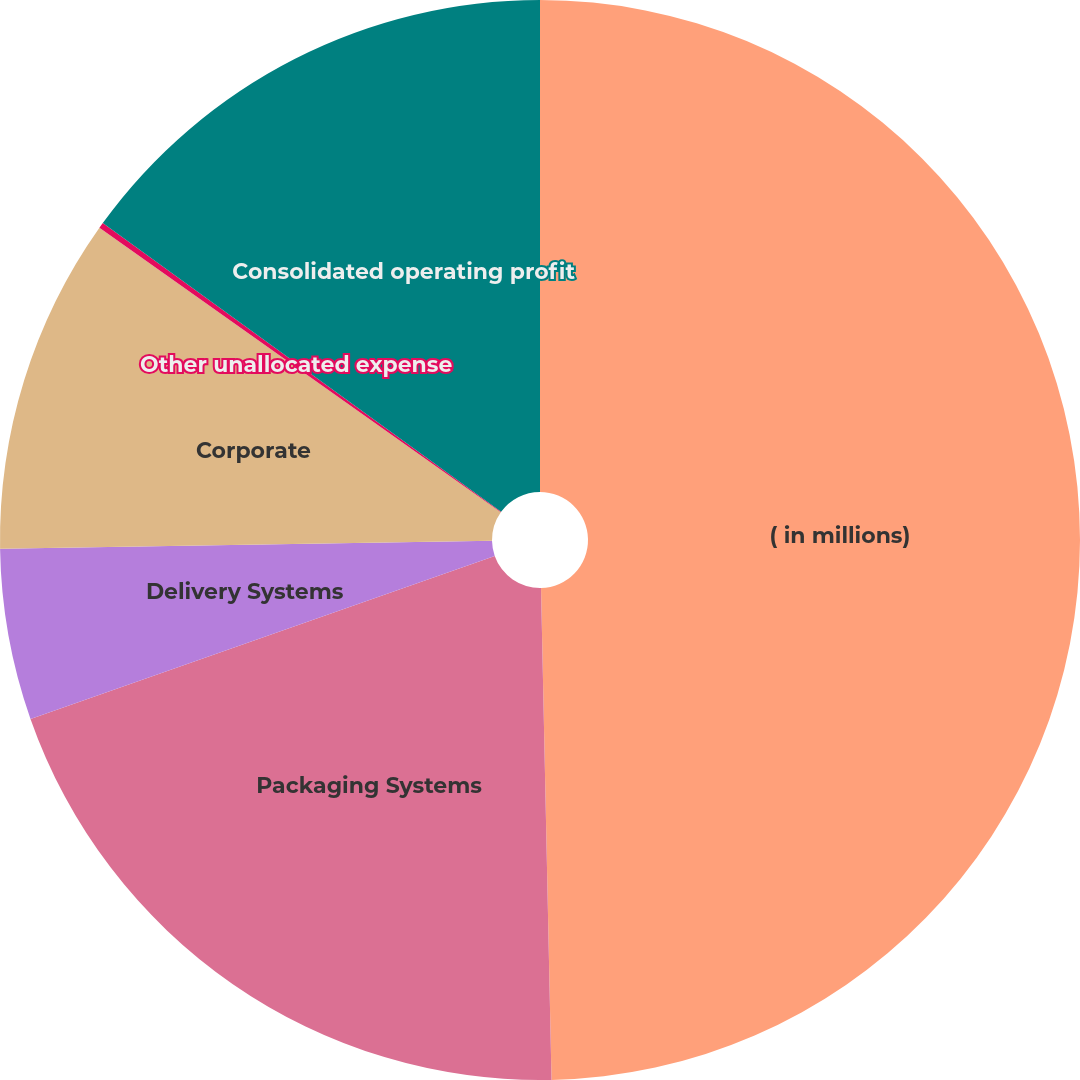<chart> <loc_0><loc_0><loc_500><loc_500><pie_chart><fcel>( in millions)<fcel>Packaging Systems<fcel>Delivery Systems<fcel>Corporate<fcel>Other unallocated expense<fcel>Consolidated operating profit<nl><fcel>49.67%<fcel>19.97%<fcel>5.12%<fcel>10.07%<fcel>0.17%<fcel>15.02%<nl></chart> 